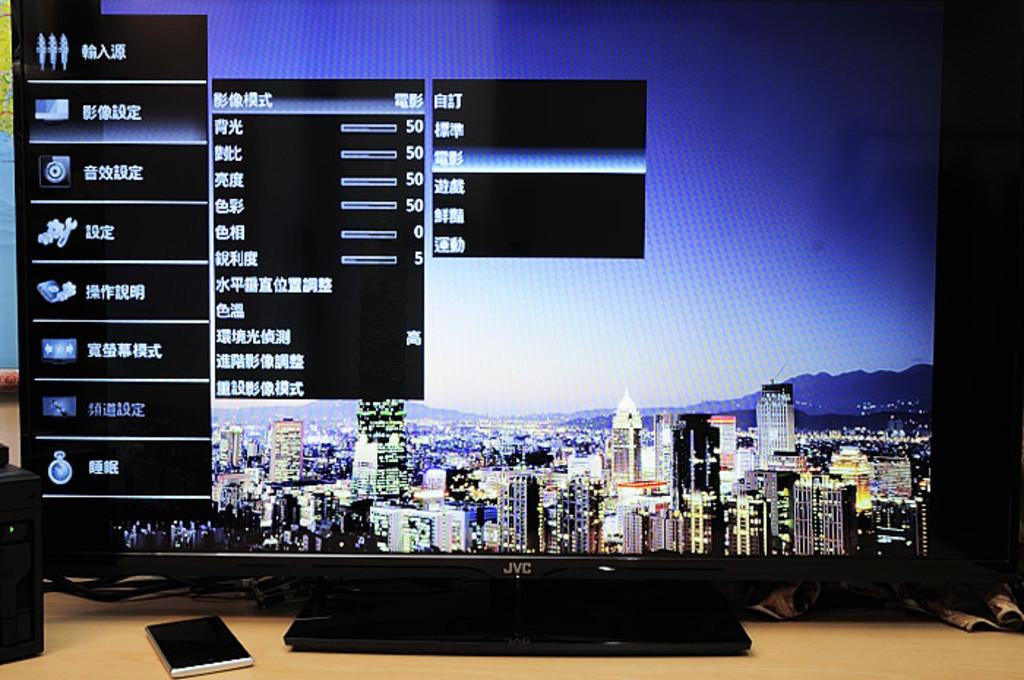<image>
Describe the image concisely. A JVC television is open to the settings menu, with a city vies as the background image. 